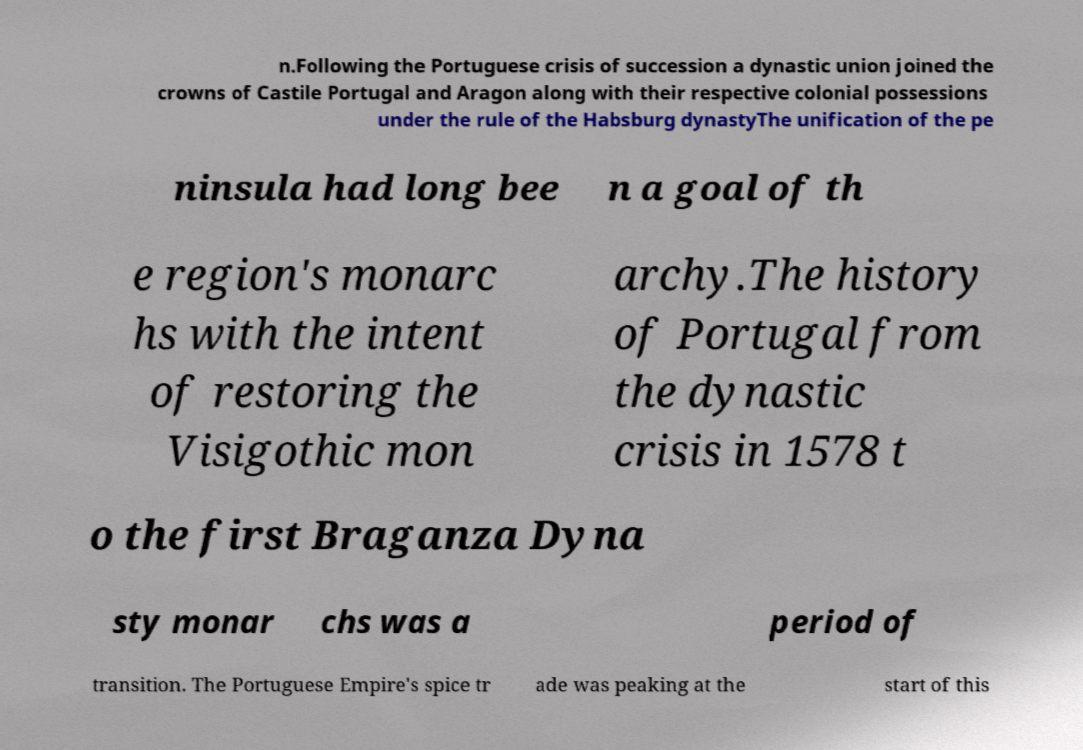There's text embedded in this image that I need extracted. Can you transcribe it verbatim? n.Following the Portuguese crisis of succession a dynastic union joined the crowns of Castile Portugal and Aragon along with their respective colonial possessions under the rule of the Habsburg dynastyThe unification of the pe ninsula had long bee n a goal of th e region's monarc hs with the intent of restoring the Visigothic mon archy.The history of Portugal from the dynastic crisis in 1578 t o the first Braganza Dyna sty monar chs was a period of transition. The Portuguese Empire's spice tr ade was peaking at the start of this 